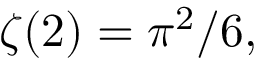Convert formula to latex. <formula><loc_0><loc_0><loc_500><loc_500>\zeta ( 2 ) = \pi ^ { 2 } / 6 ,</formula> 